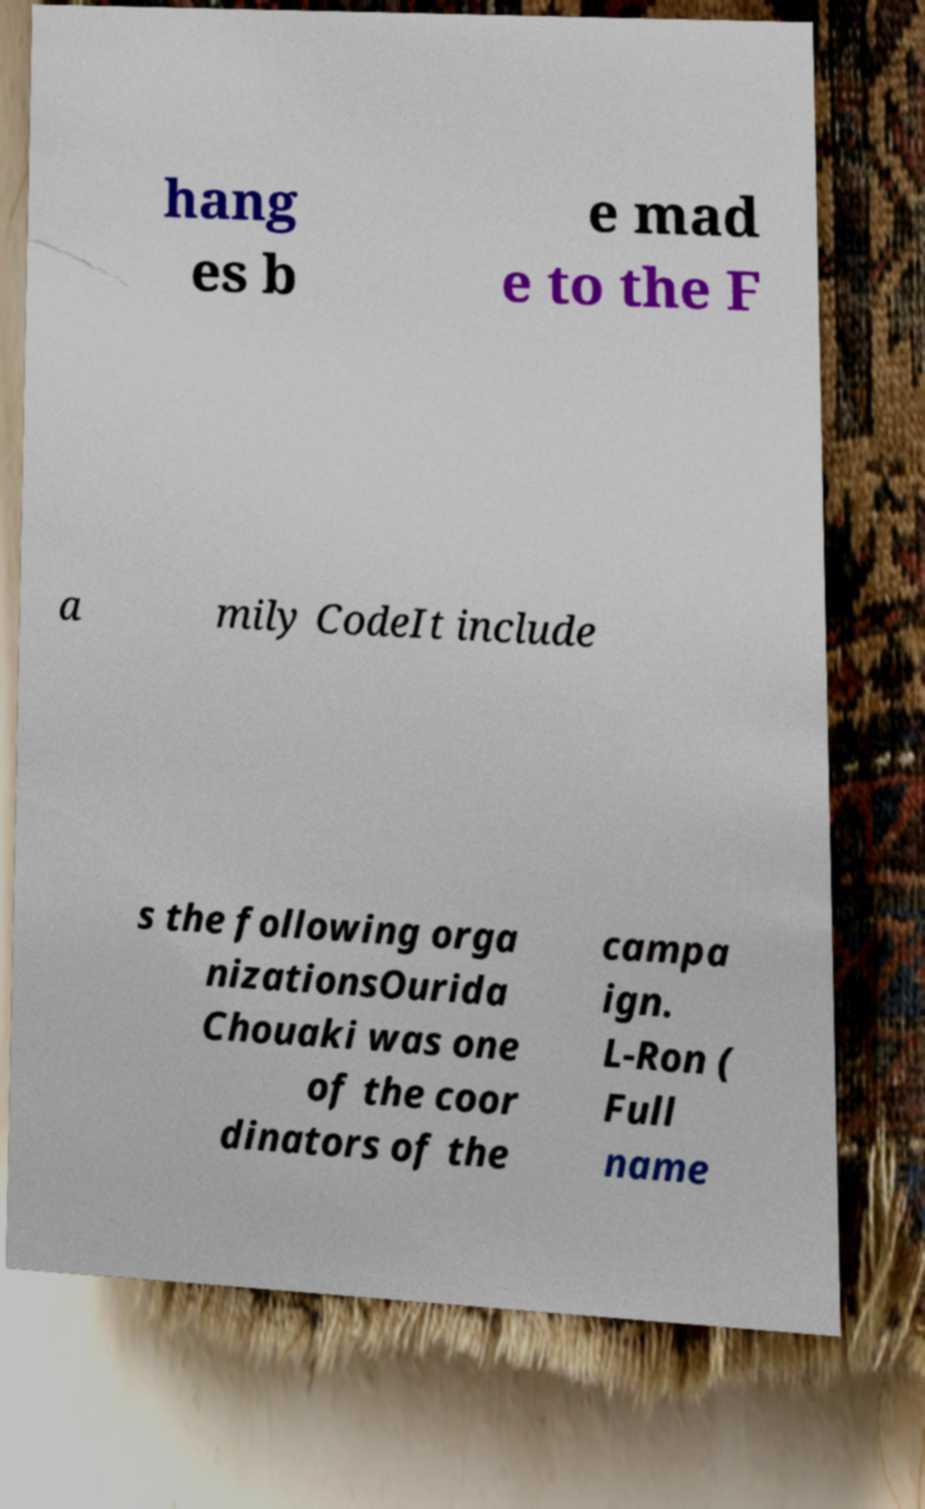Could you assist in decoding the text presented in this image and type it out clearly? hang es b e mad e to the F a mily CodeIt include s the following orga nizationsOurida Chouaki was one of the coor dinators of the campa ign. L-Ron ( Full name 